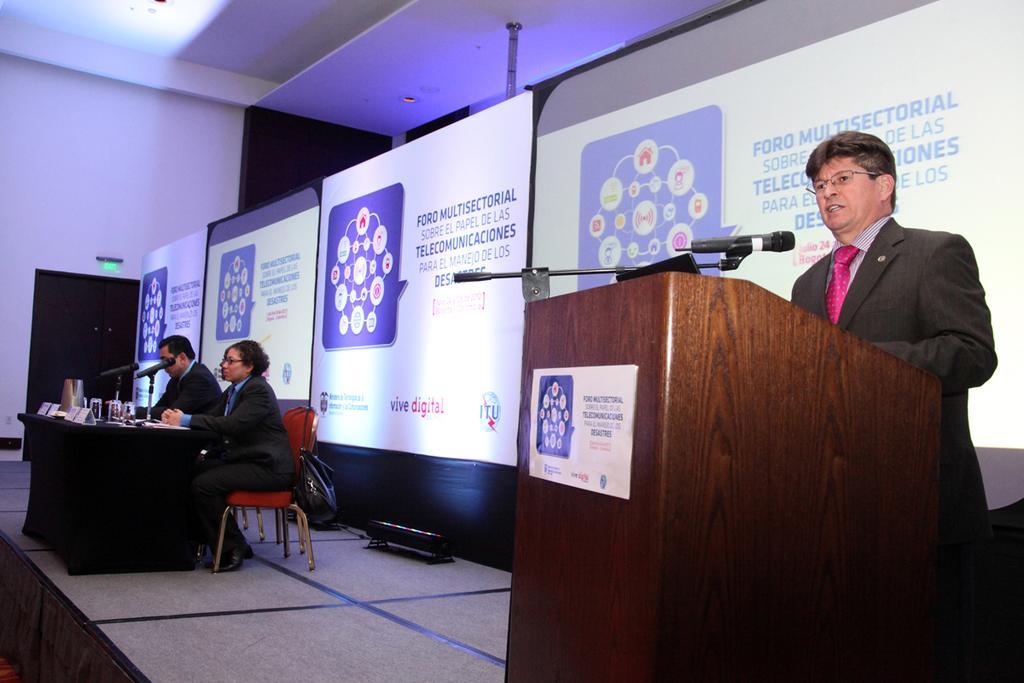Describe this image in one or two sentences. In this image there are two persons sitting on the chair, there is a bag, there is a person standing and talking, there is a podium, there is a stand, there is a microphone, there is an object on the podium, there is a paper on the podium, there is text on the paper, there are objects on the table, there are boards, there is text on the board, there is an object on the ground, there is the door, there is wall truncated towards the left of the image, there is roof truncated towards the left of the image. 